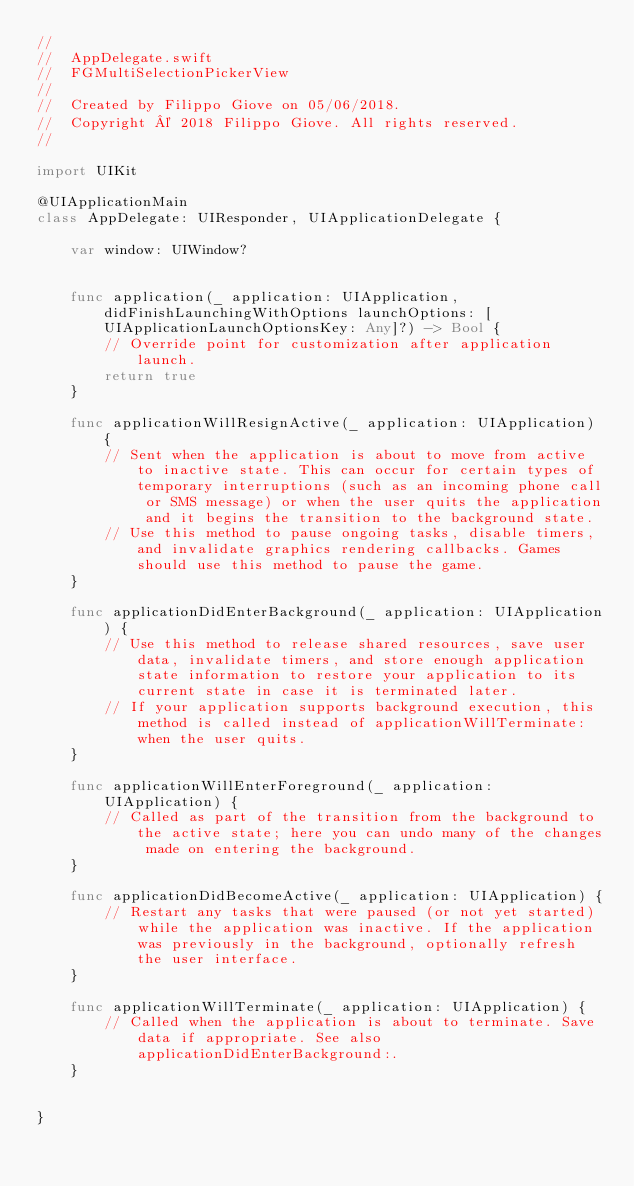Convert code to text. <code><loc_0><loc_0><loc_500><loc_500><_Swift_>//
//  AppDelegate.swift
//  FGMultiSelectionPickerView
//
//  Created by Filippo Giove on 05/06/2018.
//  Copyright © 2018 Filippo Giove. All rights reserved.
//

import UIKit

@UIApplicationMain
class AppDelegate: UIResponder, UIApplicationDelegate {

    var window: UIWindow?


    func application(_ application: UIApplication, didFinishLaunchingWithOptions launchOptions: [UIApplicationLaunchOptionsKey: Any]?) -> Bool {
        // Override point for customization after application launch.
        return true
    }

    func applicationWillResignActive(_ application: UIApplication) {
        // Sent when the application is about to move from active to inactive state. This can occur for certain types of temporary interruptions (such as an incoming phone call or SMS message) or when the user quits the application and it begins the transition to the background state.
        // Use this method to pause ongoing tasks, disable timers, and invalidate graphics rendering callbacks. Games should use this method to pause the game.
    }

    func applicationDidEnterBackground(_ application: UIApplication) {
        // Use this method to release shared resources, save user data, invalidate timers, and store enough application state information to restore your application to its current state in case it is terminated later.
        // If your application supports background execution, this method is called instead of applicationWillTerminate: when the user quits.
    }

    func applicationWillEnterForeground(_ application: UIApplication) {
        // Called as part of the transition from the background to the active state; here you can undo many of the changes made on entering the background.
    }

    func applicationDidBecomeActive(_ application: UIApplication) {
        // Restart any tasks that were paused (or not yet started) while the application was inactive. If the application was previously in the background, optionally refresh the user interface.
    }

    func applicationWillTerminate(_ application: UIApplication) {
        // Called when the application is about to terminate. Save data if appropriate. See also applicationDidEnterBackground:.
    }


}

</code> 